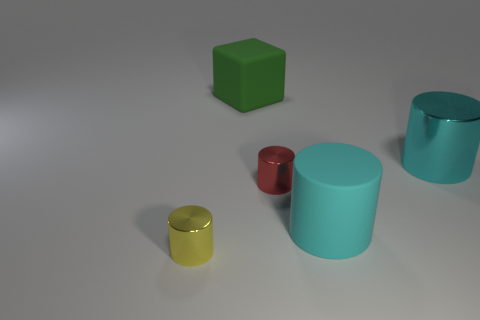Subtract all rubber cylinders. How many cylinders are left? 3 Subtract all yellow cubes. How many cyan cylinders are left? 2 Subtract all yellow cylinders. How many cylinders are left? 3 Add 2 big green rubber things. How many objects exist? 7 Subtract all blocks. How many objects are left? 4 Subtract all big blue cylinders. Subtract all green cubes. How many objects are left? 4 Add 4 big green objects. How many big green objects are left? 5 Add 4 rubber objects. How many rubber objects exist? 6 Subtract 0 purple balls. How many objects are left? 5 Subtract all yellow cylinders. Subtract all brown cubes. How many cylinders are left? 3 